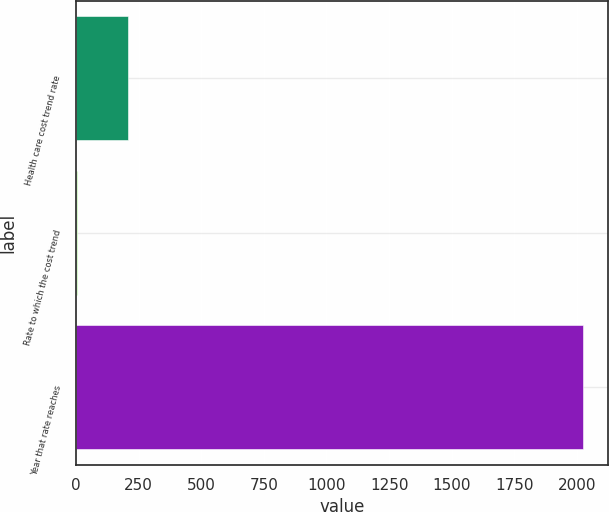Convert chart to OTSL. <chart><loc_0><loc_0><loc_500><loc_500><bar_chart><fcel>Health care cost trend rate<fcel>Rate to which the cost trend<fcel>Year that rate reaches<nl><fcel>206.68<fcel>4.75<fcel>2024<nl></chart> 